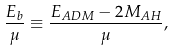Convert formula to latex. <formula><loc_0><loc_0><loc_500><loc_500>\frac { E _ { b } } { \mu } \equiv \frac { E _ { A D M } - 2 M _ { A H } } { \mu } ,</formula> 